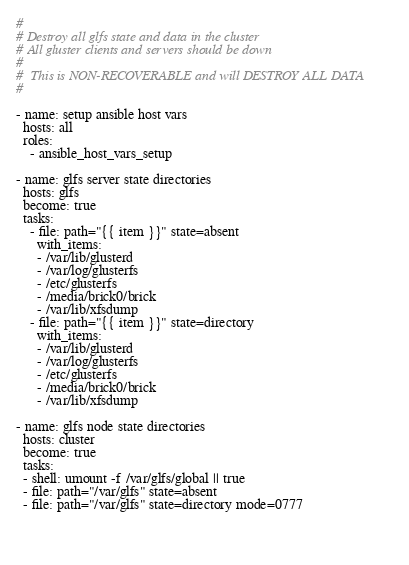Convert code to text. <code><loc_0><loc_0><loc_500><loc_500><_YAML_>#
# Destroy all glfs state and data in the cluster
# All gluster clients and servers should be down
#
#  This is NON-RECOVERABLE and will DESTROY ALL DATA
#

- name: setup ansible host vars
  hosts: all
  roles:
    - ansible_host_vars_setup

- name: glfs server state directories
  hosts: glfs
  become: true
  tasks:
    - file: path="{{ item }}" state=absent
      with_items:
      - /var/lib/glusterd
      - /var/log/glusterfs
      - /etc/glusterfs
      - /media/brick0/brick
      - /var/lib/xfsdump
    - file: path="{{ item }}" state=directory
      with_items:
      - /var/lib/glusterd
      - /var/log/glusterfs
      - /etc/glusterfs
      - /media/brick0/brick
      - /var/lib/xfsdump

- name: glfs node state directories
  hosts: cluster
  become: true
  tasks:
  - shell: umount -f /var/glfs/global || true
  - file: path="/var/glfs" state=absent
  - file: path="/var/glfs" state=directory mode=0777


  


</code> 